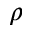Convert formula to latex. <formula><loc_0><loc_0><loc_500><loc_500>\rho</formula> 